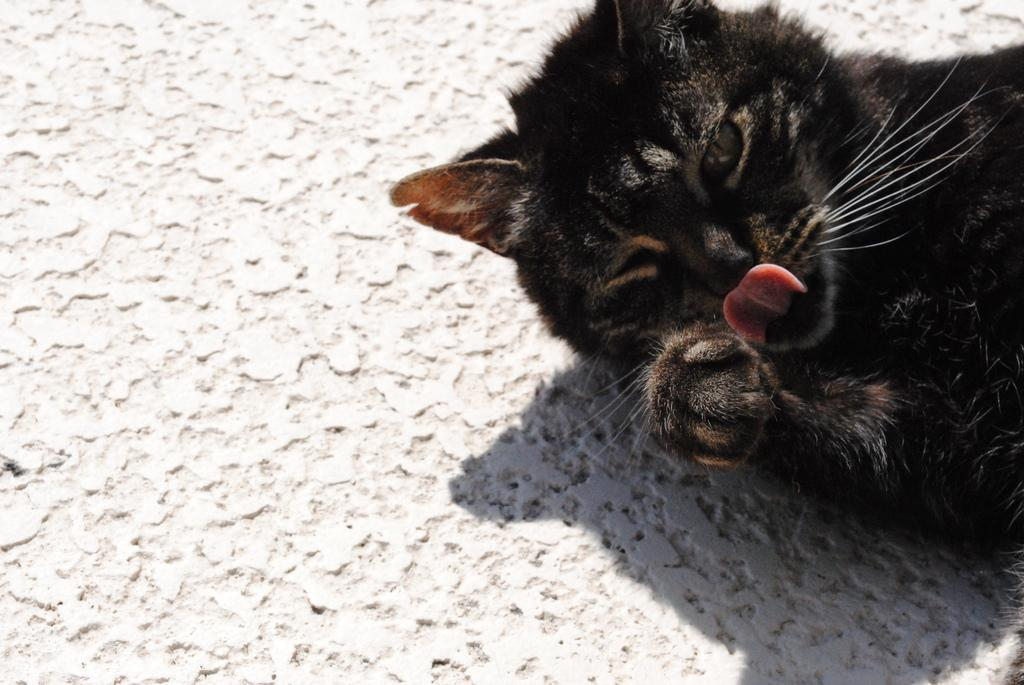What type of animal is in the image? There is a black cat in the image. What color is the surface around the cat? There is a white surface around the cat. Where is the bucket located in the image? There is no bucket present in the image. What type of rest can be seen in the image? There is no rest or resting area depicted in the image. 